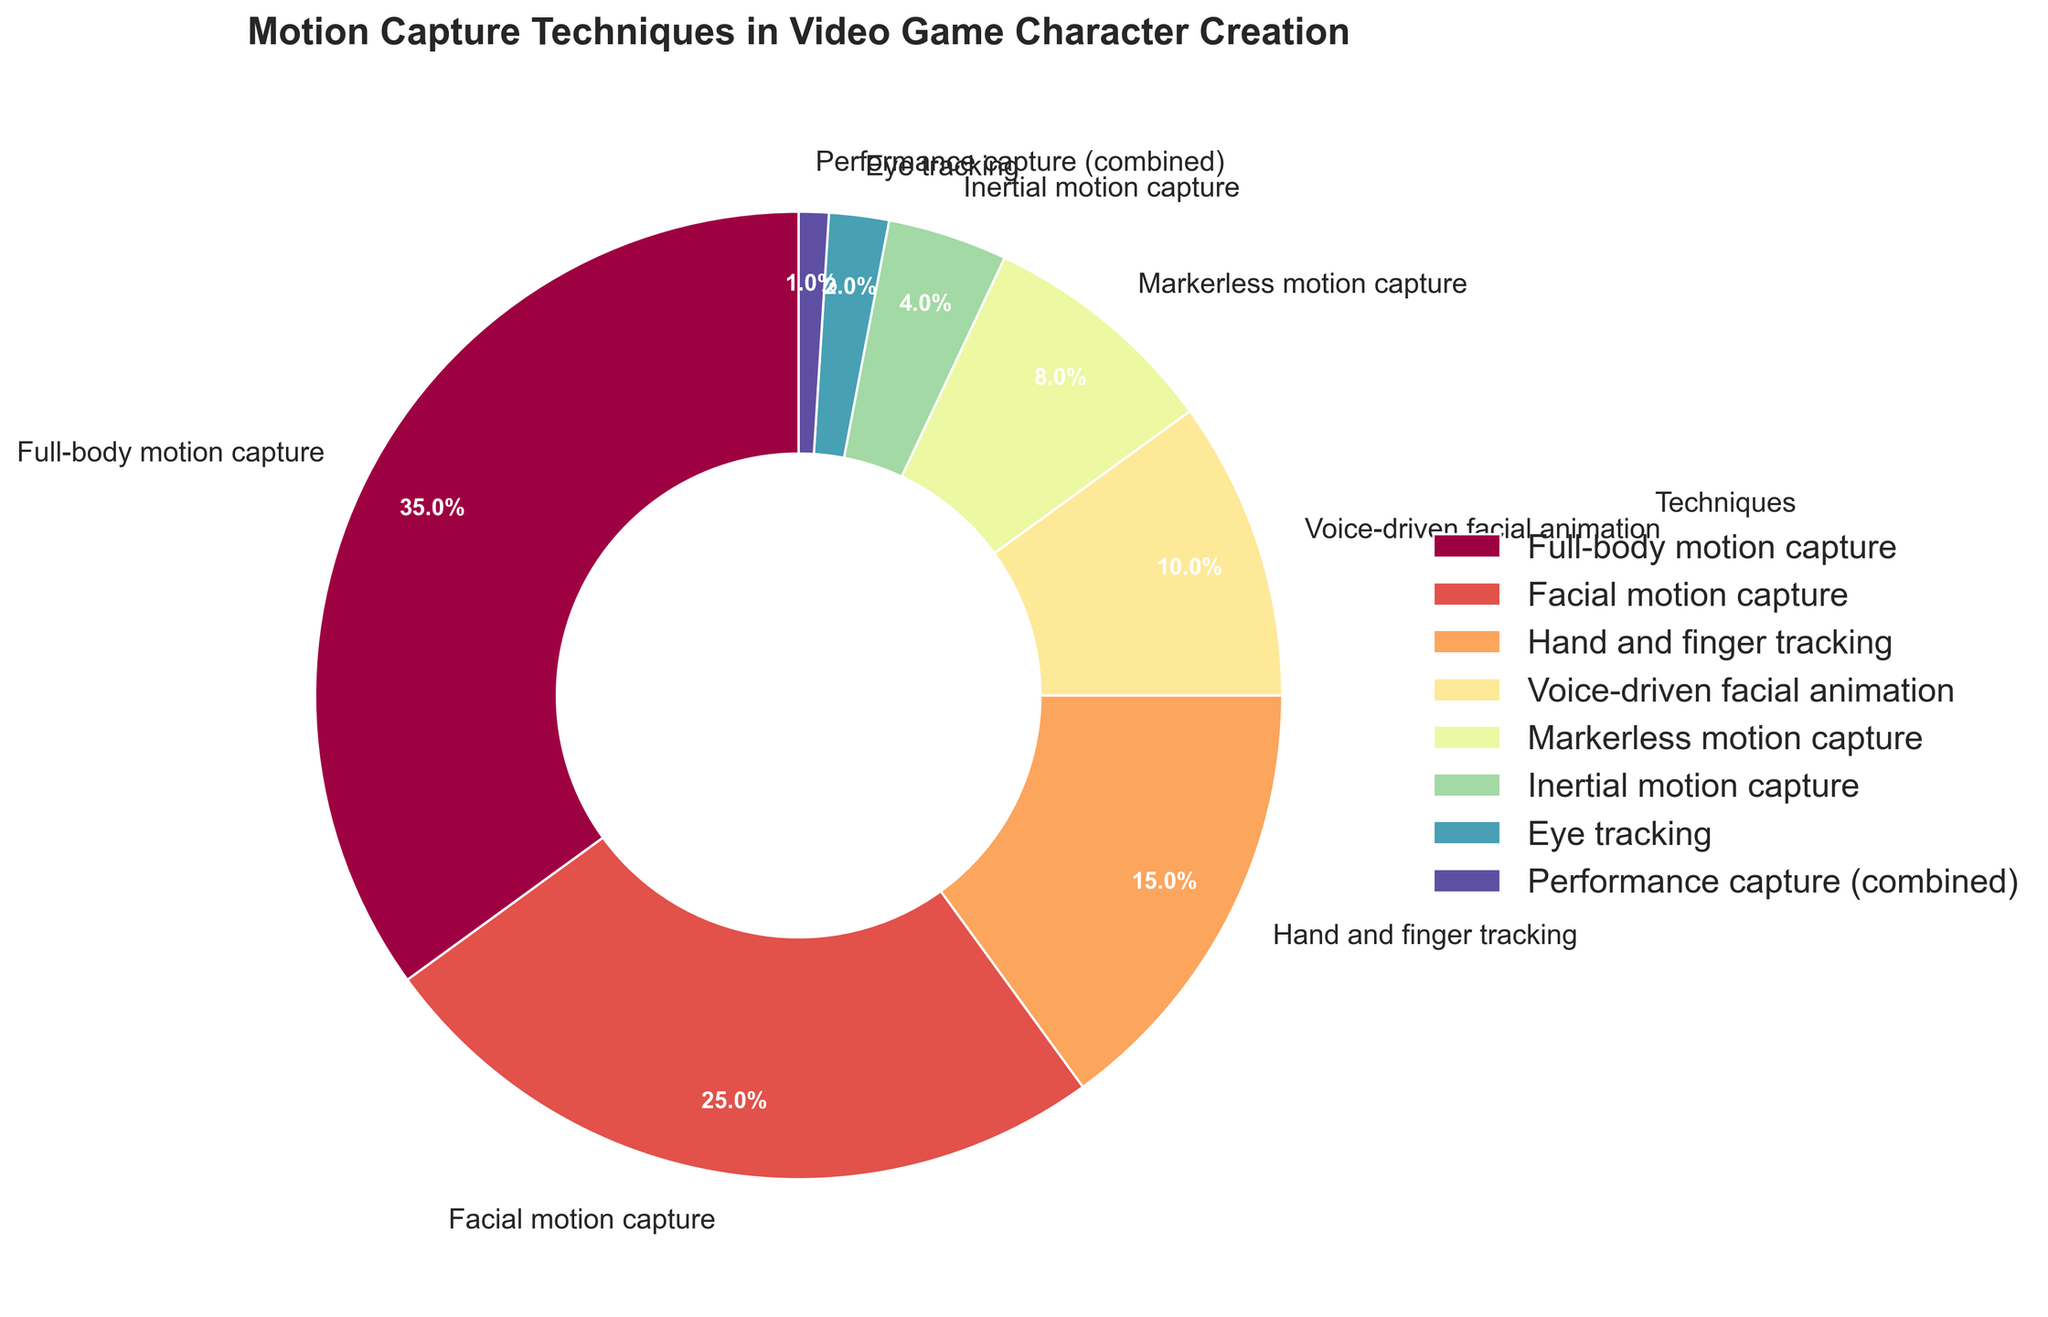What percentage of video game character creation techniques involves capturing facial movements, including both facial motion capture and voice-driven facial animation? To find the total percentage of techniques that involve capturing facial movements, add the percentages for "Facial motion capture" and "Voice-driven facial animation". These are 25% and 10% respectively. Therefore, 25% + 10% = 35%.
Answer: 35% Which motion capture technique is used the least frequently in video game character creation? By observing the pie chart, we see that "Performance capture (combined)" occupies the smallest wedge, indicating it has the smallest percentage.
Answer: Performance capture (combined) How does the percentage of facial motion capture compare to that of full-body motion capture? The percentage of facial motion capture is 25%, and that of full-body motion capture is 35%. So, facial motion capture is less than full-body motion capture by 10%.
Answer: Facial motion capture is 10% less than full-body motion capture What is the combined percentage of all motion capture techniques that involve tracking of finer details (i.e., hand and finger tracking, eye tracking)? We combine the percentages for "Hand and finger tracking" (15%) and "Eye tracking" (2%). Adding them together, 15% + 2% = 17%.
Answer: 17% If a new technique were introduced that takes up 10% of the total, how would this affect the percentage of full-body motion capture? If the total is currently 100%, adding a new technique with 10% would increase the total to 110%. To find the new percentage of full-body motion capture, use the formula: (Current Percentage / New Total) * 100% = (35 / 110) * 100% ≈ 31.82%.
Answer: Approximately 31.82% Rank the techniques from most to least commonly used in video game character creation. From the pie chart, the techniques in descending order of their percentages are: Full-body motion capture (35%), Facial motion capture (25%), Hand and finger tracking (15%), Voice-driven facial animation (10%), Markerless motion capture (8%), Inertial motion capture (4%), Eye tracking (2%), Performance capture (combined) (1%).
Answer: Full-body motion capture, Facial motion capture, Hand and finger tracking, Voice-driven facial animation, Markerless motion capture, Inertial motion capture, Eye tracking, Performance capture (combined) If we merge "Markerless motion capture" and "Inertial motion capture" into one category, what would be its new percentage? The current percentages for "Markerless motion capture" and "Inertial motion capture" are 8% and 4% respectively. Adding them together, 8% + 4% = 12%.
Answer: 12% What percentage of techniques involves only parts of the body (like hand and finger tracking, eye tracking, etc.) rather than the full body? Techniques involving only parts of the body are "Facial motion capture" (25%), "Hand and finger tracking" (15%), "Voice-driven facial animation" (10%), "Markerless motion capture" (8%), "Inertial motion capture" (4%), and "Eye tracking" (2%). Adding these percentages gives: 25% + 15% + 10% + 8% + 4% + 2% = 64%.
Answer: 64% 